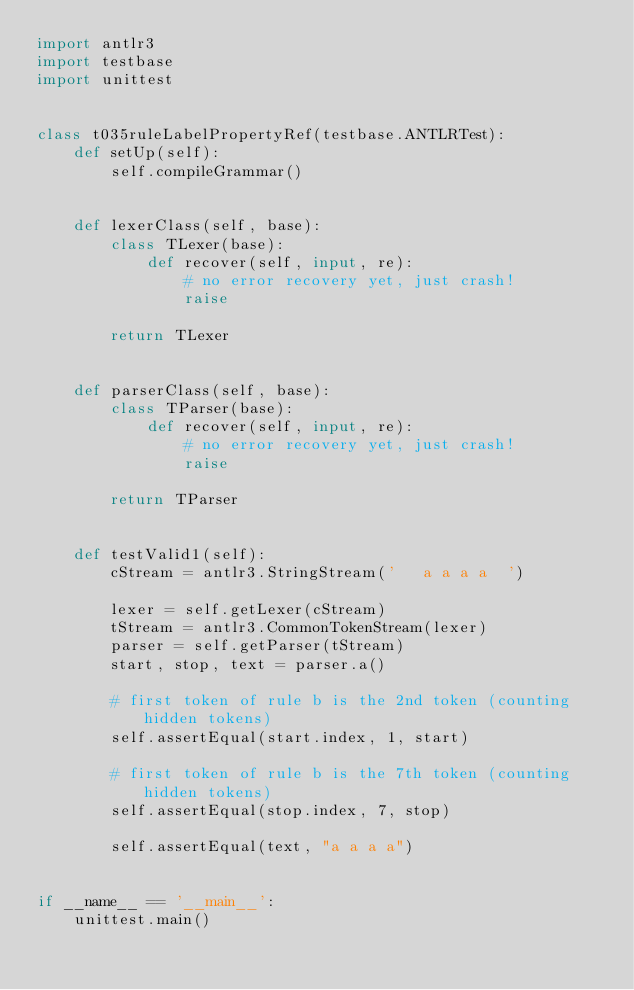<code> <loc_0><loc_0><loc_500><loc_500><_Python_>import antlr3
import testbase
import unittest


class t035ruleLabelPropertyRef(testbase.ANTLRTest):
    def setUp(self):
        self.compileGrammar()
        

    def lexerClass(self, base):
        class TLexer(base):
            def recover(self, input, re):
                # no error recovery yet, just crash!
                raise

        return TLexer
    
        
    def parserClass(self, base):
        class TParser(base):
            def recover(self, input, re):
                # no error recovery yet, just crash!
                raise

        return TParser
    
        
    def testValid1(self):
        cStream = antlr3.StringStream('   a a a a  ')

        lexer = self.getLexer(cStream)
        tStream = antlr3.CommonTokenStream(lexer)
        parser = self.getParser(tStream)
        start, stop, text = parser.a()

        # first token of rule b is the 2nd token (counting hidden tokens)
        self.assertEqual(start.index, 1, start)

        # first token of rule b is the 7th token (counting hidden tokens)
        self.assertEqual(stop.index, 7, stop)

        self.assertEqual(text, "a a a a")


if __name__ == '__main__':
    unittest.main()
</code> 